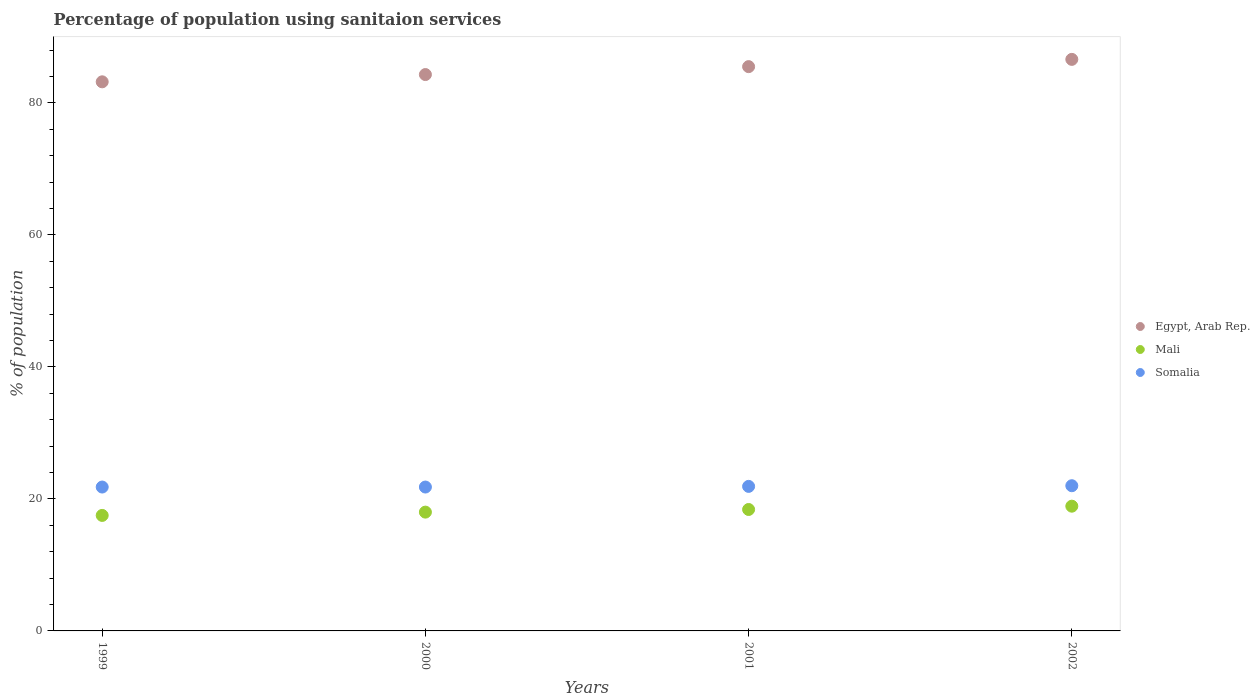How many different coloured dotlines are there?
Offer a very short reply. 3. What is the percentage of population using sanitaion services in Egypt, Arab Rep. in 2001?
Provide a short and direct response. 85.5. Across all years, what is the maximum percentage of population using sanitaion services in Somalia?
Provide a succinct answer. 22. Across all years, what is the minimum percentage of population using sanitaion services in Mali?
Ensure brevity in your answer.  17.5. In which year was the percentage of population using sanitaion services in Somalia maximum?
Your response must be concise. 2002. In which year was the percentage of population using sanitaion services in Mali minimum?
Your answer should be compact. 1999. What is the total percentage of population using sanitaion services in Egypt, Arab Rep. in the graph?
Your answer should be compact. 339.6. What is the difference between the percentage of population using sanitaion services in Somalia in 2000 and that in 2001?
Give a very brief answer. -0.1. What is the difference between the percentage of population using sanitaion services in Somalia in 1999 and the percentage of population using sanitaion services in Egypt, Arab Rep. in 2001?
Offer a terse response. -63.7. What is the average percentage of population using sanitaion services in Mali per year?
Offer a very short reply. 18.2. What is the ratio of the percentage of population using sanitaion services in Mali in 2001 to that in 2002?
Provide a succinct answer. 0.97. Is the percentage of population using sanitaion services in Egypt, Arab Rep. in 1999 less than that in 2000?
Your answer should be compact. Yes. Is the difference between the percentage of population using sanitaion services in Mali in 2000 and 2001 greater than the difference between the percentage of population using sanitaion services in Somalia in 2000 and 2001?
Your answer should be very brief. No. What is the difference between the highest and the second highest percentage of population using sanitaion services in Egypt, Arab Rep.?
Offer a very short reply. 1.1. What is the difference between the highest and the lowest percentage of population using sanitaion services in Egypt, Arab Rep.?
Offer a very short reply. 3.4. Is the sum of the percentage of population using sanitaion services in Egypt, Arab Rep. in 1999 and 2002 greater than the maximum percentage of population using sanitaion services in Mali across all years?
Your response must be concise. Yes. Is the percentage of population using sanitaion services in Egypt, Arab Rep. strictly less than the percentage of population using sanitaion services in Mali over the years?
Your answer should be compact. No. Are the values on the major ticks of Y-axis written in scientific E-notation?
Your answer should be compact. No. What is the title of the graph?
Provide a succinct answer. Percentage of population using sanitaion services. What is the label or title of the X-axis?
Give a very brief answer. Years. What is the label or title of the Y-axis?
Provide a short and direct response. % of population. What is the % of population of Egypt, Arab Rep. in 1999?
Your response must be concise. 83.2. What is the % of population of Mali in 1999?
Offer a very short reply. 17.5. What is the % of population of Somalia in 1999?
Offer a terse response. 21.8. What is the % of population in Egypt, Arab Rep. in 2000?
Your answer should be compact. 84.3. What is the % of population of Somalia in 2000?
Provide a succinct answer. 21.8. What is the % of population of Egypt, Arab Rep. in 2001?
Keep it short and to the point. 85.5. What is the % of population in Mali in 2001?
Provide a short and direct response. 18.4. What is the % of population of Somalia in 2001?
Keep it short and to the point. 21.9. What is the % of population in Egypt, Arab Rep. in 2002?
Provide a succinct answer. 86.6. Across all years, what is the maximum % of population of Egypt, Arab Rep.?
Keep it short and to the point. 86.6. Across all years, what is the maximum % of population of Mali?
Provide a succinct answer. 18.9. Across all years, what is the minimum % of population in Egypt, Arab Rep.?
Provide a short and direct response. 83.2. Across all years, what is the minimum % of population in Mali?
Your response must be concise. 17.5. Across all years, what is the minimum % of population in Somalia?
Your answer should be very brief. 21.8. What is the total % of population in Egypt, Arab Rep. in the graph?
Offer a terse response. 339.6. What is the total % of population in Mali in the graph?
Keep it short and to the point. 72.8. What is the total % of population of Somalia in the graph?
Give a very brief answer. 87.5. What is the difference between the % of population in Mali in 1999 and that in 2000?
Provide a short and direct response. -0.5. What is the difference between the % of population in Somalia in 1999 and that in 2000?
Provide a succinct answer. 0. What is the difference between the % of population in Mali in 1999 and that in 2002?
Your answer should be compact. -1.4. What is the difference between the % of population in Somalia in 1999 and that in 2002?
Provide a succinct answer. -0.2. What is the difference between the % of population in Egypt, Arab Rep. in 2000 and that in 2001?
Ensure brevity in your answer.  -1.2. What is the difference between the % of population in Egypt, Arab Rep. in 2000 and that in 2002?
Provide a short and direct response. -2.3. What is the difference between the % of population of Somalia in 2000 and that in 2002?
Your answer should be compact. -0.2. What is the difference between the % of population of Egypt, Arab Rep. in 2001 and that in 2002?
Keep it short and to the point. -1.1. What is the difference between the % of population in Mali in 2001 and that in 2002?
Make the answer very short. -0.5. What is the difference between the % of population in Somalia in 2001 and that in 2002?
Provide a succinct answer. -0.1. What is the difference between the % of population of Egypt, Arab Rep. in 1999 and the % of population of Mali in 2000?
Offer a very short reply. 65.2. What is the difference between the % of population in Egypt, Arab Rep. in 1999 and the % of population in Somalia in 2000?
Give a very brief answer. 61.4. What is the difference between the % of population in Mali in 1999 and the % of population in Somalia in 2000?
Provide a succinct answer. -4.3. What is the difference between the % of population in Egypt, Arab Rep. in 1999 and the % of population in Mali in 2001?
Your response must be concise. 64.8. What is the difference between the % of population of Egypt, Arab Rep. in 1999 and the % of population of Somalia in 2001?
Give a very brief answer. 61.3. What is the difference between the % of population of Mali in 1999 and the % of population of Somalia in 2001?
Ensure brevity in your answer.  -4.4. What is the difference between the % of population of Egypt, Arab Rep. in 1999 and the % of population of Mali in 2002?
Make the answer very short. 64.3. What is the difference between the % of population of Egypt, Arab Rep. in 1999 and the % of population of Somalia in 2002?
Ensure brevity in your answer.  61.2. What is the difference between the % of population of Egypt, Arab Rep. in 2000 and the % of population of Mali in 2001?
Provide a succinct answer. 65.9. What is the difference between the % of population of Egypt, Arab Rep. in 2000 and the % of population of Somalia in 2001?
Offer a terse response. 62.4. What is the difference between the % of population in Egypt, Arab Rep. in 2000 and the % of population in Mali in 2002?
Your response must be concise. 65.4. What is the difference between the % of population of Egypt, Arab Rep. in 2000 and the % of population of Somalia in 2002?
Your answer should be very brief. 62.3. What is the difference between the % of population in Egypt, Arab Rep. in 2001 and the % of population in Mali in 2002?
Provide a succinct answer. 66.6. What is the difference between the % of population of Egypt, Arab Rep. in 2001 and the % of population of Somalia in 2002?
Ensure brevity in your answer.  63.5. What is the difference between the % of population of Mali in 2001 and the % of population of Somalia in 2002?
Your response must be concise. -3.6. What is the average % of population in Egypt, Arab Rep. per year?
Your answer should be very brief. 84.9. What is the average % of population in Mali per year?
Your answer should be very brief. 18.2. What is the average % of population of Somalia per year?
Offer a terse response. 21.88. In the year 1999, what is the difference between the % of population in Egypt, Arab Rep. and % of population in Mali?
Make the answer very short. 65.7. In the year 1999, what is the difference between the % of population of Egypt, Arab Rep. and % of population of Somalia?
Your answer should be compact. 61.4. In the year 1999, what is the difference between the % of population in Mali and % of population in Somalia?
Your answer should be very brief. -4.3. In the year 2000, what is the difference between the % of population of Egypt, Arab Rep. and % of population of Mali?
Your response must be concise. 66.3. In the year 2000, what is the difference between the % of population in Egypt, Arab Rep. and % of population in Somalia?
Provide a short and direct response. 62.5. In the year 2001, what is the difference between the % of population of Egypt, Arab Rep. and % of population of Mali?
Ensure brevity in your answer.  67.1. In the year 2001, what is the difference between the % of population in Egypt, Arab Rep. and % of population in Somalia?
Offer a terse response. 63.6. In the year 2002, what is the difference between the % of population of Egypt, Arab Rep. and % of population of Mali?
Make the answer very short. 67.7. In the year 2002, what is the difference between the % of population of Egypt, Arab Rep. and % of population of Somalia?
Keep it short and to the point. 64.6. What is the ratio of the % of population of Egypt, Arab Rep. in 1999 to that in 2000?
Give a very brief answer. 0.99. What is the ratio of the % of population in Mali in 1999 to that in 2000?
Provide a succinct answer. 0.97. What is the ratio of the % of population in Egypt, Arab Rep. in 1999 to that in 2001?
Ensure brevity in your answer.  0.97. What is the ratio of the % of population of Mali in 1999 to that in 2001?
Provide a succinct answer. 0.95. What is the ratio of the % of population in Egypt, Arab Rep. in 1999 to that in 2002?
Your answer should be compact. 0.96. What is the ratio of the % of population in Mali in 1999 to that in 2002?
Keep it short and to the point. 0.93. What is the ratio of the % of population of Somalia in 1999 to that in 2002?
Your response must be concise. 0.99. What is the ratio of the % of population of Mali in 2000 to that in 2001?
Your answer should be very brief. 0.98. What is the ratio of the % of population in Somalia in 2000 to that in 2001?
Offer a very short reply. 1. What is the ratio of the % of population of Egypt, Arab Rep. in 2000 to that in 2002?
Provide a succinct answer. 0.97. What is the ratio of the % of population of Mali in 2000 to that in 2002?
Ensure brevity in your answer.  0.95. What is the ratio of the % of population of Somalia in 2000 to that in 2002?
Provide a succinct answer. 0.99. What is the ratio of the % of population in Egypt, Arab Rep. in 2001 to that in 2002?
Offer a very short reply. 0.99. What is the ratio of the % of population of Mali in 2001 to that in 2002?
Provide a short and direct response. 0.97. What is the difference between the highest and the second highest % of population in Somalia?
Your answer should be compact. 0.1. What is the difference between the highest and the lowest % of population in Mali?
Your answer should be very brief. 1.4. What is the difference between the highest and the lowest % of population in Somalia?
Your response must be concise. 0.2. 